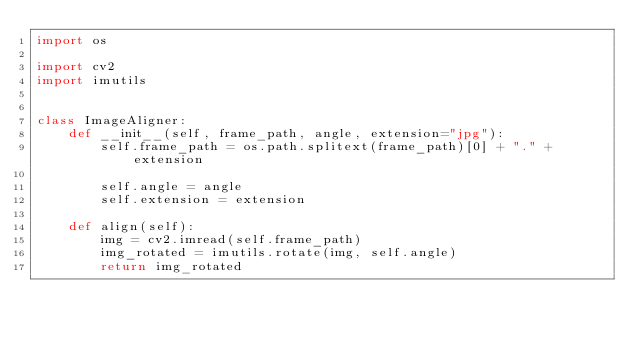<code> <loc_0><loc_0><loc_500><loc_500><_Python_>import os

import cv2
import imutils


class ImageAligner:
    def __init__(self, frame_path, angle, extension="jpg"):
        self.frame_path = os.path.splitext(frame_path)[0] + "." + extension

        self.angle = angle
        self.extension = extension

    def align(self):
        img = cv2.imread(self.frame_path)
        img_rotated = imutils.rotate(img, self.angle)
        return img_rotated
</code> 